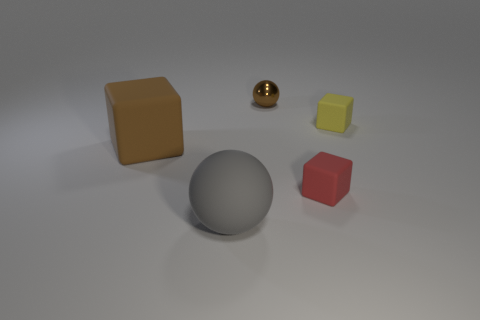Add 5 small blue shiny balls. How many objects exist? 10 Subtract all small blocks. How many blocks are left? 1 Subtract 1 blocks. How many blocks are left? 2 Subtract all balls. How many objects are left? 3 Add 5 small brown spheres. How many small brown spheres exist? 6 Subtract all yellow blocks. How many blocks are left? 2 Subtract 0 brown cylinders. How many objects are left? 5 Subtract all gray spheres. Subtract all gray blocks. How many spheres are left? 1 Subtract all cyan balls. How many brown cubes are left? 1 Subtract all small blue balls. Subtract all big matte balls. How many objects are left? 4 